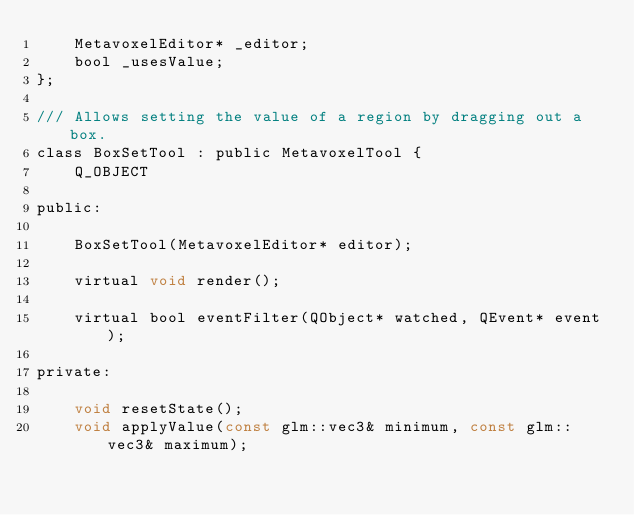Convert code to text. <code><loc_0><loc_0><loc_500><loc_500><_C_>    MetavoxelEditor* _editor;
    bool _usesValue;
};

/// Allows setting the value of a region by dragging out a box.
class BoxSetTool : public MetavoxelTool {
    Q_OBJECT

public:
    
    BoxSetTool(MetavoxelEditor* editor);

    virtual void render();

    virtual bool eventFilter(QObject* watched, QEvent* event);

private:
    
    void resetState();
    void applyValue(const glm::vec3& minimum, const glm::vec3& maximum);
    </code> 